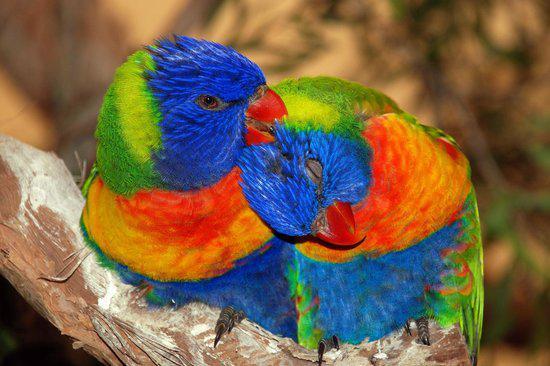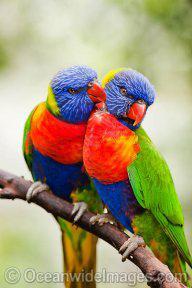The first image is the image on the left, the second image is the image on the right. Analyze the images presented: Is the assertion "Four colorful birds are perched outside." valid? Answer yes or no. Yes. The first image is the image on the left, the second image is the image on the right. Analyze the images presented: Is the assertion "Each image contains one pair of multicolor parrots." valid? Answer yes or no. Yes. 